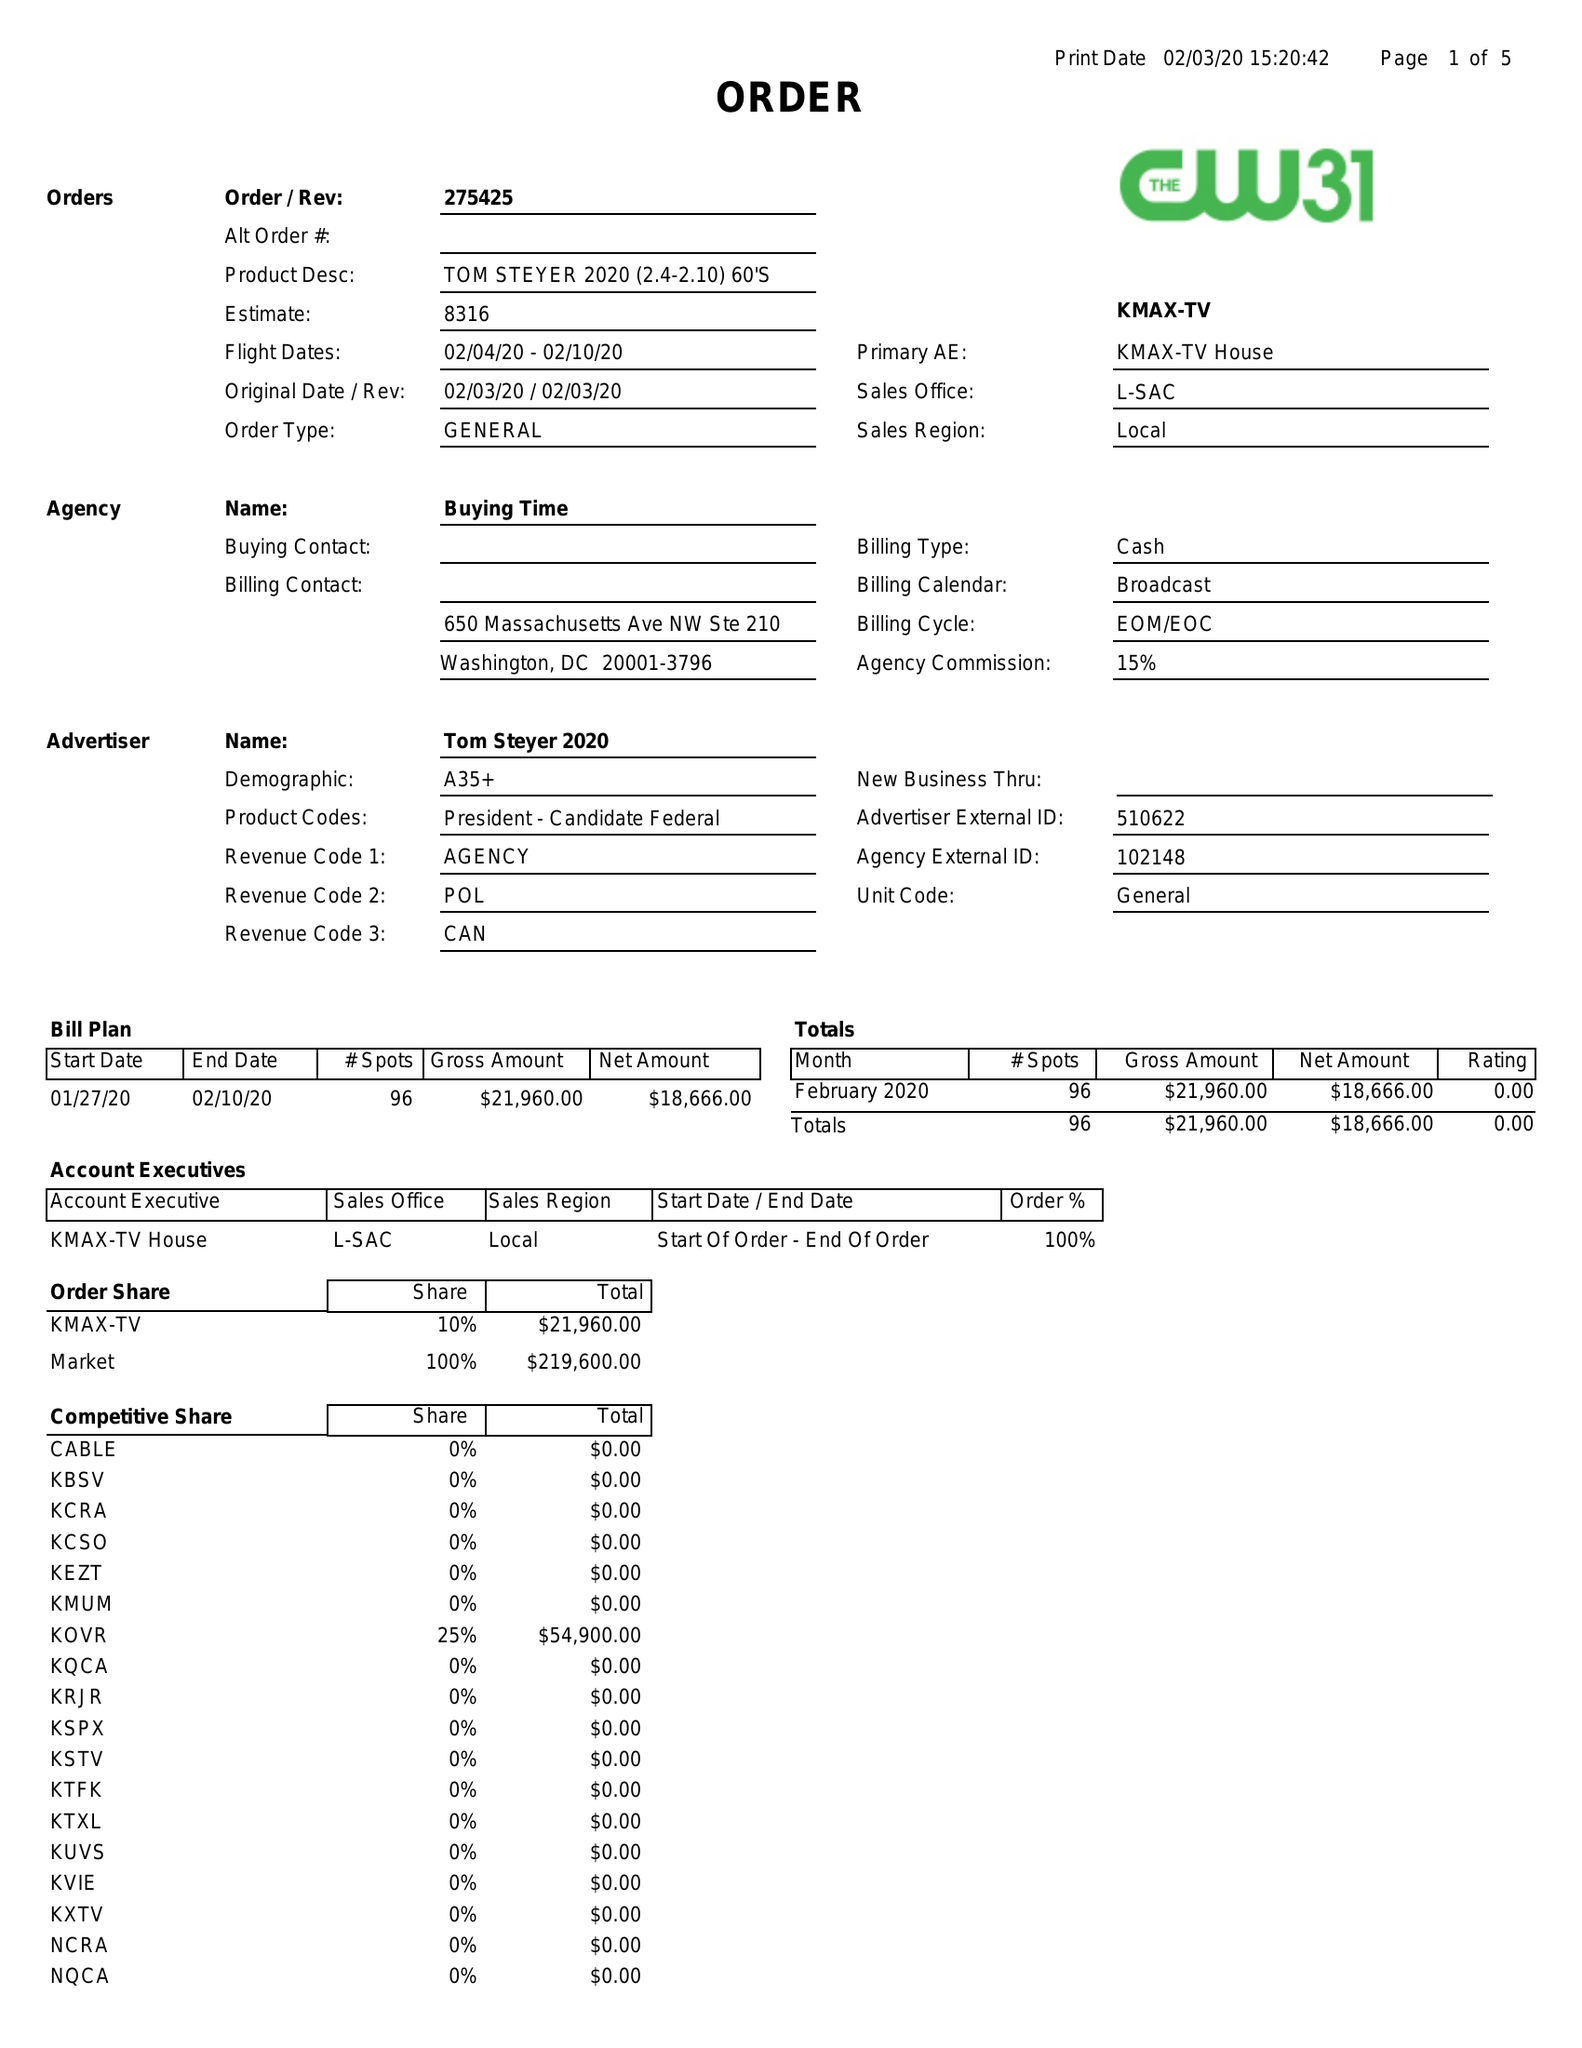What is the value for the flight_from?
Answer the question using a single word or phrase. 02/04/20 